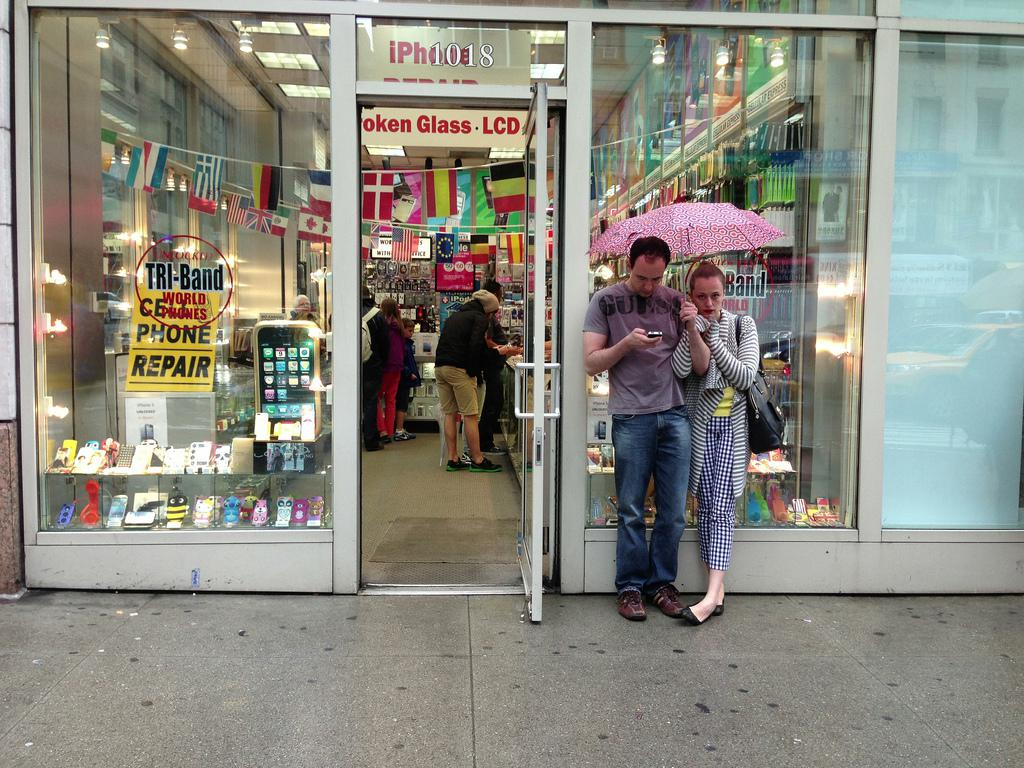Question: what are the two people outside the shop holding?
Choices:
A. The bags of clothes they just bought.
B. Cups of fresh coffee.
C. An umbrella.
D. Slices of pizza.
Answer with the letter. Answer: C Question: who is holding an umbrella?
Choices:
A. The pregnant woman.
B. The elderly gentleman.
C. The guy and girl.
D. The young couple.
Answer with the letter. Answer: C Question: how is the guy dressed?
Choices:
A. Shorts and a wife beater.
B. A suit and tie.
C. In a speedo and moccasins.
D. Jeans and t-shirt.
Answer with the letter. Answer: D Question: what shop is in the picture?
Choices:
A. Pizza parlor.
B. iPhone repair.
C. Bridal wear.
D. Home and garden.
Answer with the letter. Answer: B Question: where are they people with the umbrella standing?
Choices:
A. On the street.
B. In the alley.
C. In the doorway.
D. Outside the shop.
Answer with the letter. Answer: D Question: what color is the umbrella the people are standing under?
Choices:
A. Red.
B. Green.
C. Black.
D. Pink.
Answer with the letter. Answer: D Question: what does the yellow sign advertise?
Choices:
A. Computer help.
B. Itunes Gift Cards.
C. Verizon Wireless.
D. Cell phone repairs.
Answer with the letter. Answer: D Question: what does the store front look like?
Choices:
A. White with clear glass.
B. Wood with frosted glass.
C. Glass with metal framework.
D. Wood with hanging flowers.
Answer with the letter. Answer: C Question: what is displayed?
Choices:
A. Cell phones.
B. Purses.
C. Colorful cellphone accessories.
D. Lap Top Cases.
Answer with the letter. Answer: C Question: what's propped open on the store?
Choices:
A. The window.
B. The closet.
C. The door.
D. The freezer.
Answer with the letter. Answer: C Question: what sign is in the store window?
Choices:
A. A sale sign.
B. Cell phone repair.
C. A warning sign.
D. A welcome sign.
Answer with the letter. Answer: B Question: who is in the store shopping?
Choices:
A. Several people.
B. A carpenter.
C. A teacher.
D. A mother.
Answer with the letter. Answer: A Question: how are the overhead lights inside the store?
Choices:
A. Bright.
B. Well lit.
C. On.
D. Dim lit.
Answer with the letter. Answer: C Question: how many people are sharing an umbrella?
Choices:
A. Three.
B. Four.
C. Six.
D. Two.
Answer with the letter. Answer: D Question: how does the ground look?
Choices:
A. Wet.
B. Dirty.
C. Soft.
D. Grassy.
Answer with the letter. Answer: B 